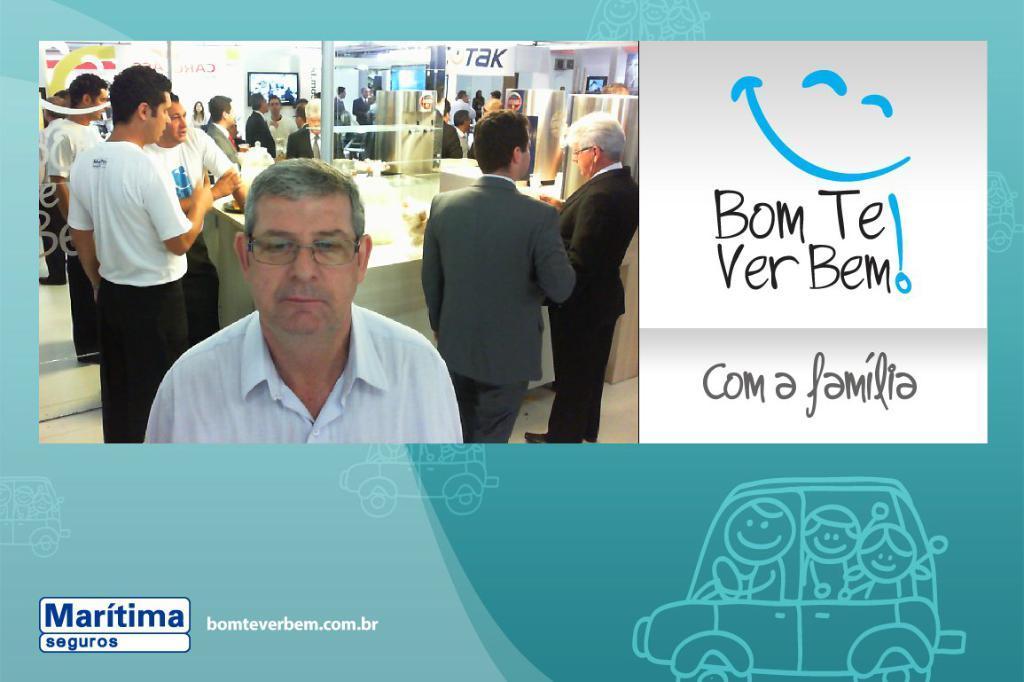In one or two sentences, can you explain what this image depicts? In this image we can see a poster in which there is a picture of some people, screens and some other things and also we can see something written. 